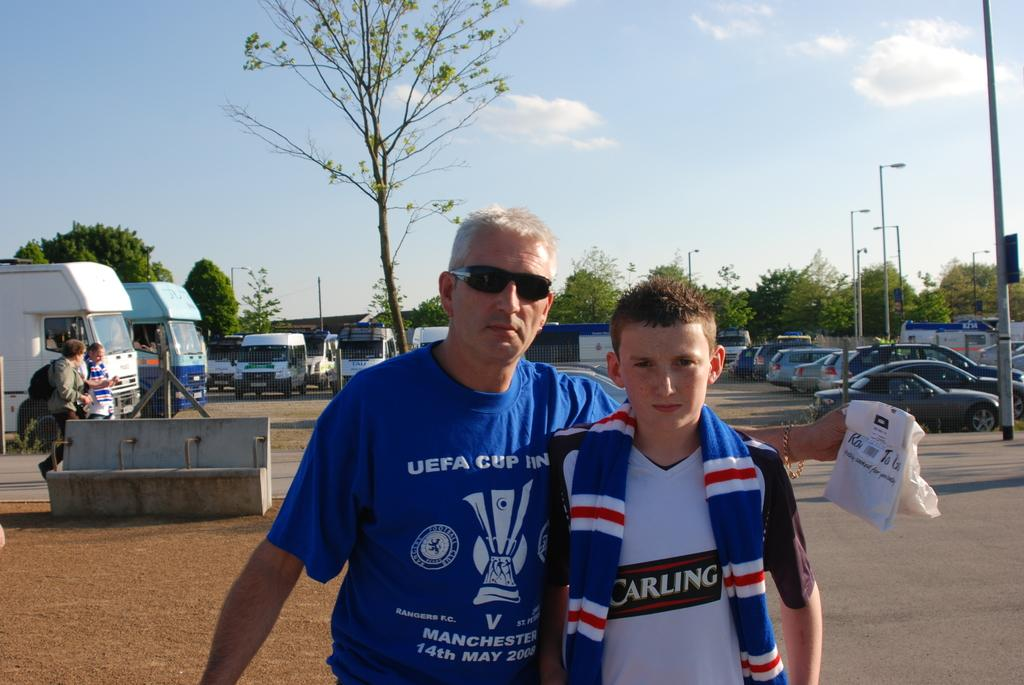<image>
Write a terse but informative summary of the picture. A man has a Manchester 14th May 2008 blue shirt on and a boy has on a shirt saying CARLING. 